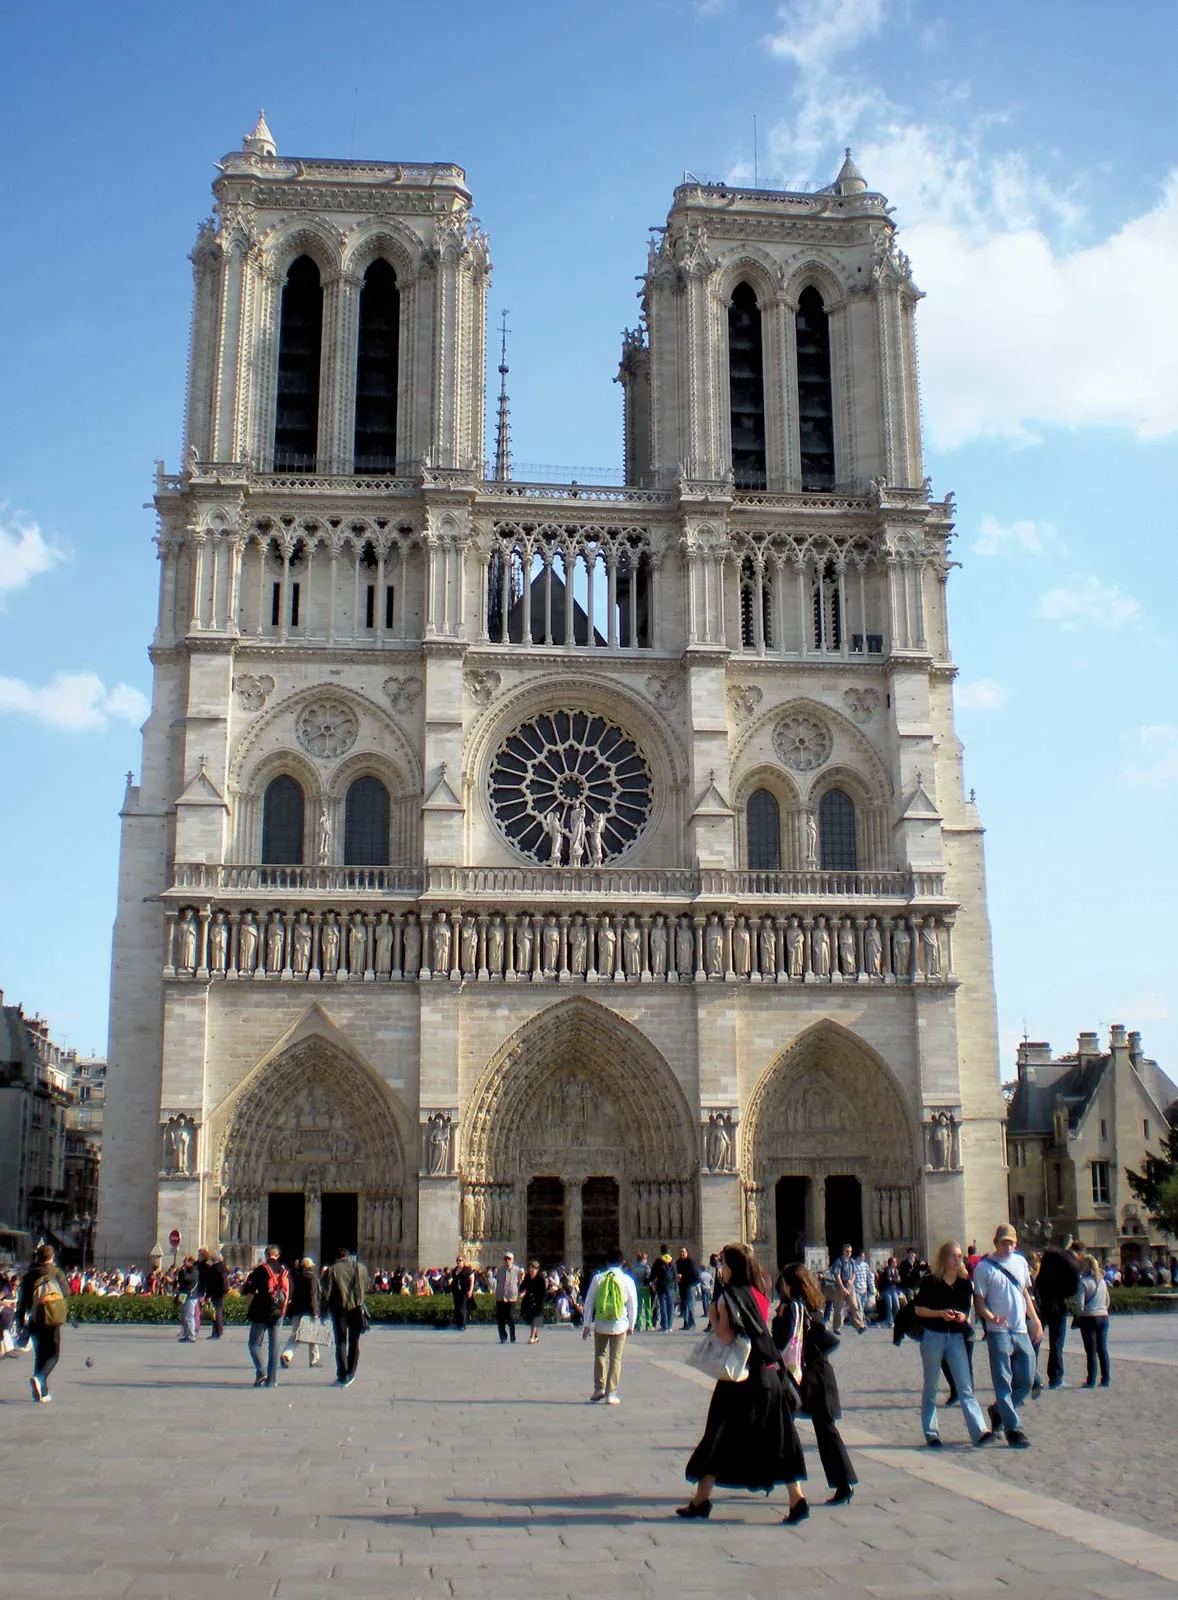How does the cathedral's exterior sculpture reflect the cultural and religious beliefs of the time it was built? The exterior sculptures of Notre Dame Cathedral are rich in cultural and religious symbolism, reflecting the beliefs and values of the medieval period when it was constructed. The gargoyles, often perceived as grotesque figures, served both a functional purpose as waterspouts and a symbolic role in warding off evil spirits. The detailed carvings of saints, apostles, and biblical scenes on the facade and portals serve as both religious iconography and a didactic tool to convey stories of faith to the congregation, many of whom were illiterate at the time. These sculptures were designed to inspire awe and reverence, reminding the faithful of the divine power and the moral teachings of the Church. Additionally, the inclusion of secular figures and scenes from daily life introduces a cultural element, illustrating the interconnectedness of the sacred and the mundane in medieval society. 